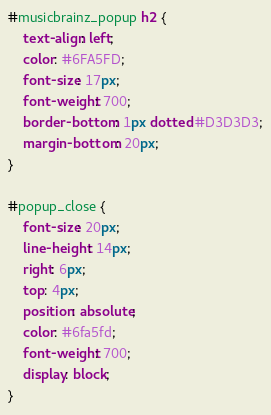Convert code to text. <code><loc_0><loc_0><loc_500><loc_500><_CSS_>#musicbrainz_popup h2 {
    text-align: left;
    color: #6FA5FD;
    font-size: 17px;
    font-weight: 700;
    border-bottom: 1px dotted #D3D3D3;
    margin-bottom: 20px;
}

#popup_close {
    font-size: 20px;
    line-height: 14px;
    right: 6px;
    top: 4px;
    position: absolute;
    color: #6fa5fd;
    font-weight: 700;
    display: block;
}
</code> 